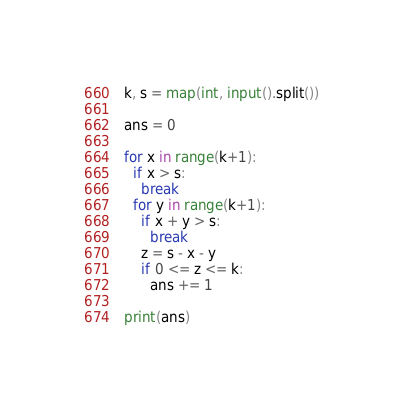Convert code to text. <code><loc_0><loc_0><loc_500><loc_500><_Python_>k, s = map(int, input().split())

ans = 0

for x in range(k+1):
  if x > s:
    break
  for y in range(k+1):
    if x + y > s:
      break
    z = s - x - y
    if 0 <= z <= k:
      ans += 1

print(ans)</code> 